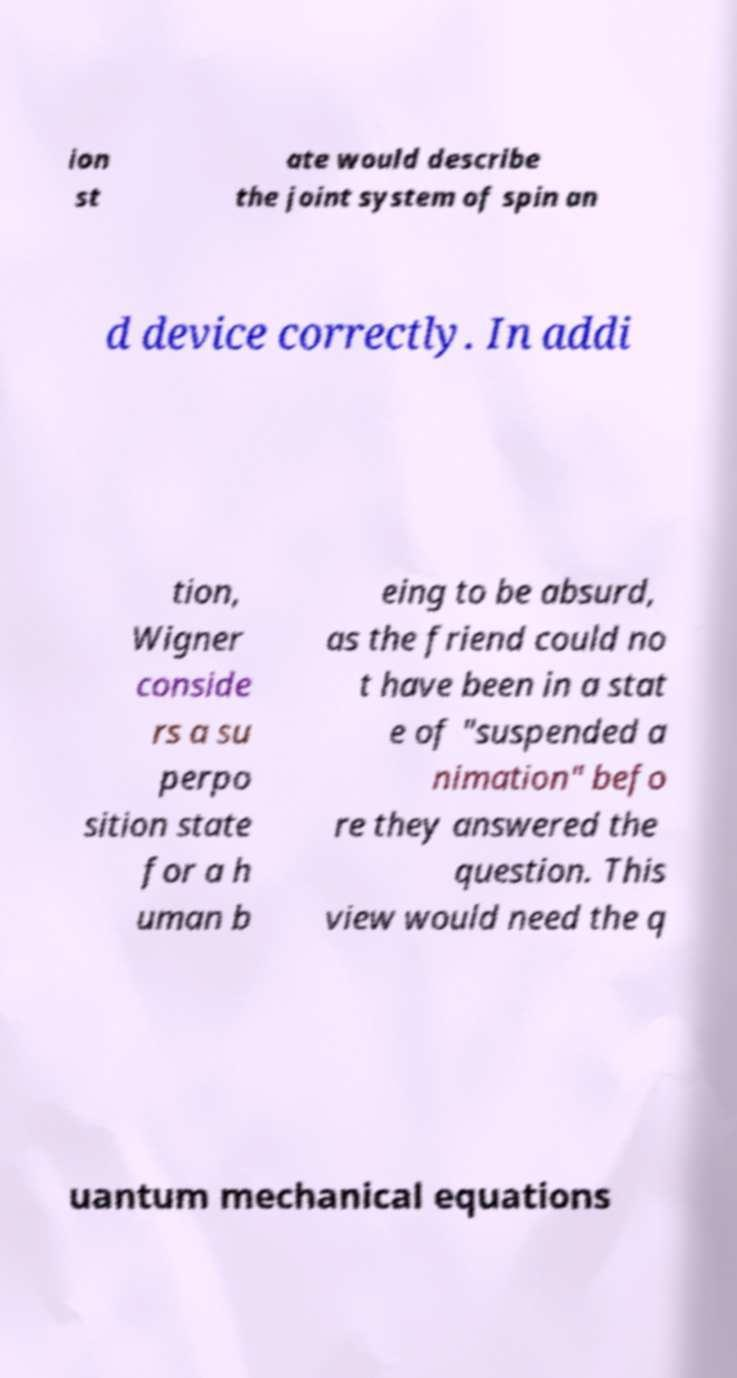I need the written content from this picture converted into text. Can you do that? ion st ate would describe the joint system of spin an d device correctly. In addi tion, Wigner conside rs a su perpo sition state for a h uman b eing to be absurd, as the friend could no t have been in a stat e of "suspended a nimation" befo re they answered the question. This view would need the q uantum mechanical equations 